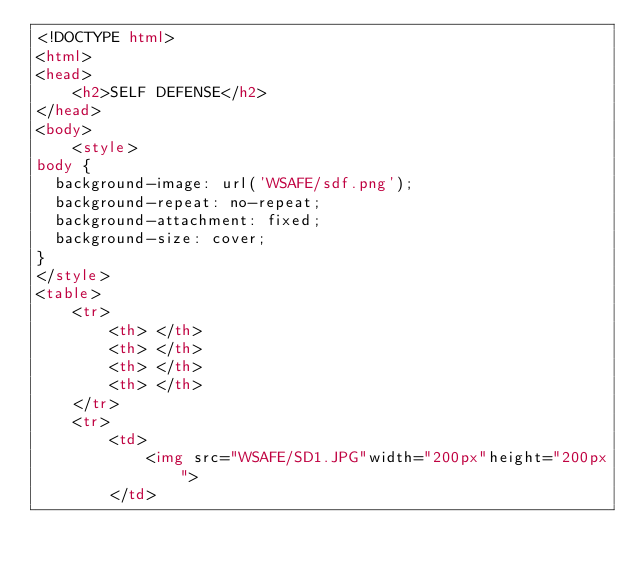Convert code to text. <code><loc_0><loc_0><loc_500><loc_500><_HTML_><!DOCTYPE html>
<html>
<head>
	<h2>SELF DEFENSE</h2>
</head>
<body>
	<style>
body {
  background-image: url('WSAFE/sdf.png');
  background-repeat: no-repeat;
  background-attachment: fixed;
  background-size: cover;
}
</style>
<table>
	<tr>
		<th> </th>
		<th> </th>
		<th> </th>
		<th> </th>
	</tr>
	<tr>
		<td>
			<img src="WSAFE/SD1.JPG"width="200px"height="200px">
		</td></code> 